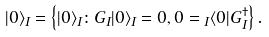Convert formula to latex. <formula><loc_0><loc_0><loc_500><loc_500>| 0 \rangle _ { I } = \left \{ | 0 \rangle _ { I } \colon G _ { I } | 0 \rangle _ { I } = 0 , 0 = { _ { I } } \langle 0 | G _ { I } ^ { \dagger } \right \} .</formula> 